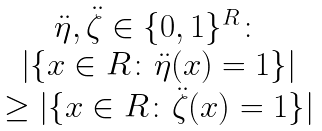<formula> <loc_0><loc_0><loc_500><loc_500>\begin{matrix} \ddot { \eta } , \ddot { \zeta } \in \{ 0 , 1 \} ^ { R } \colon \\ | \{ x \in R \colon \ddot { \eta } ( x ) = 1 \} | \\ \geq | \{ x \in R \colon \ddot { \zeta } ( x ) = 1 \} | \end{matrix}</formula> 